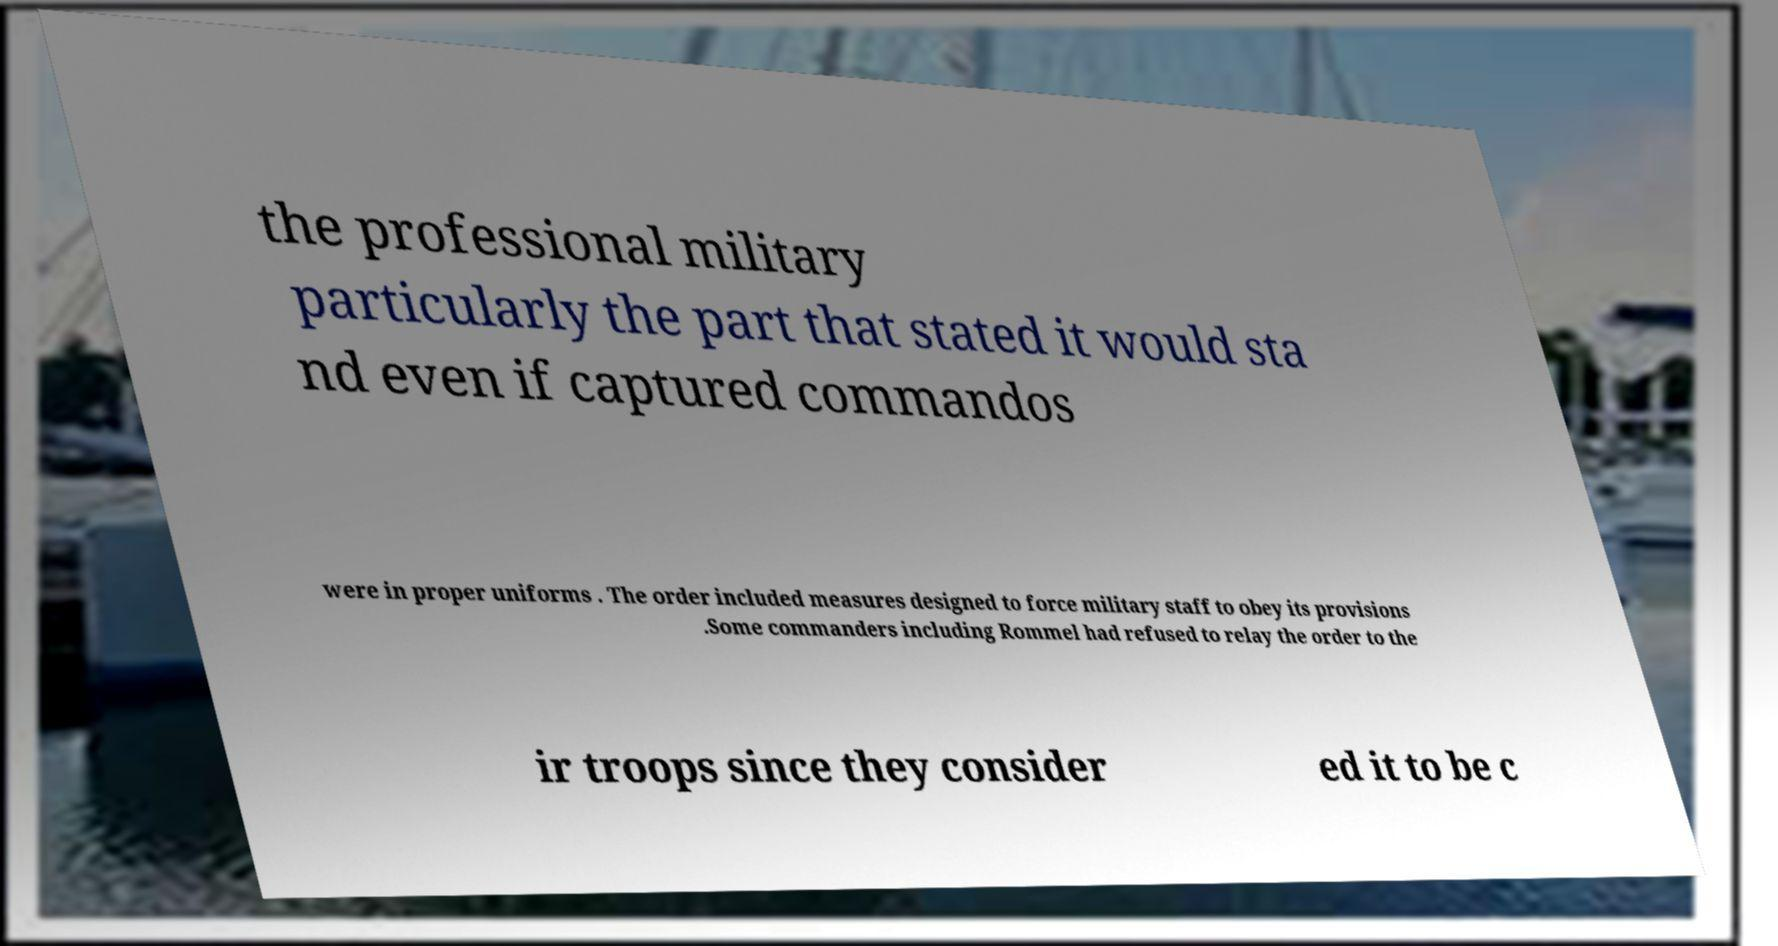What messages or text are displayed in this image? I need them in a readable, typed format. the professional military particularly the part that stated it would sta nd even if captured commandos were in proper uniforms . The order included measures designed to force military staff to obey its provisions .Some commanders including Rommel had refused to relay the order to the ir troops since they consider ed it to be c 